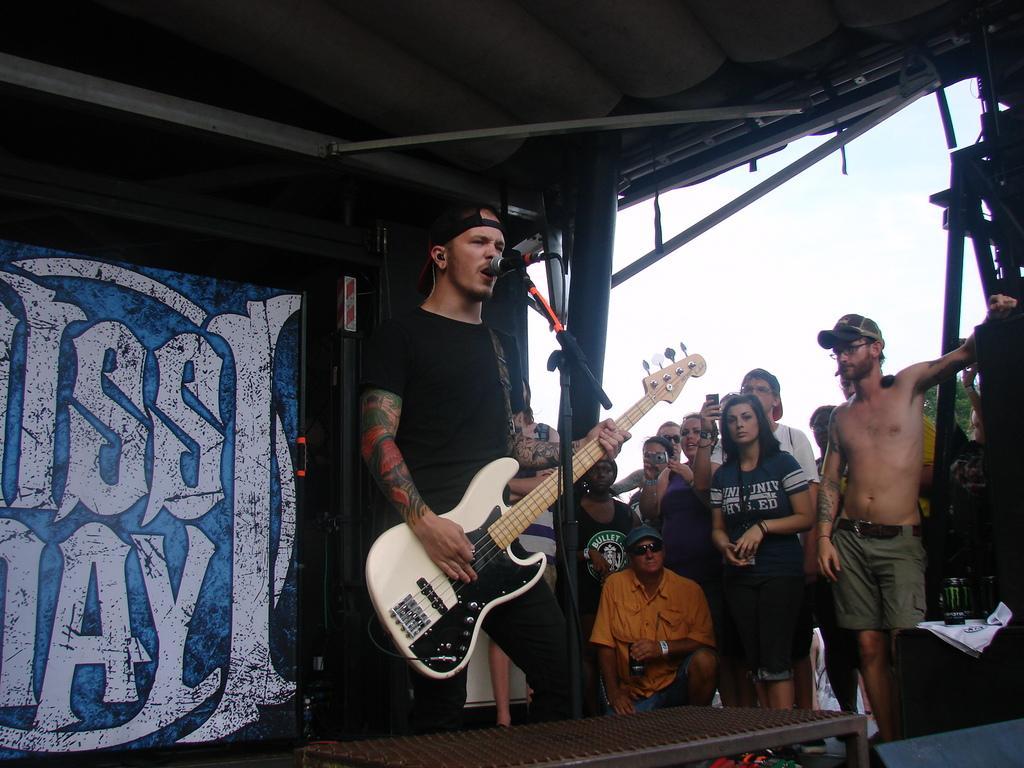Could you give a brief overview of what you see in this image? In the middle of this image I can see a man wearing black color dress and standing. He's holding a guitar in his hands and it seems like he's singing a song. In front of this person there is a mike stand. On the bottom of the image there is a table. Beside this person there are few people standing and looking at this person. 